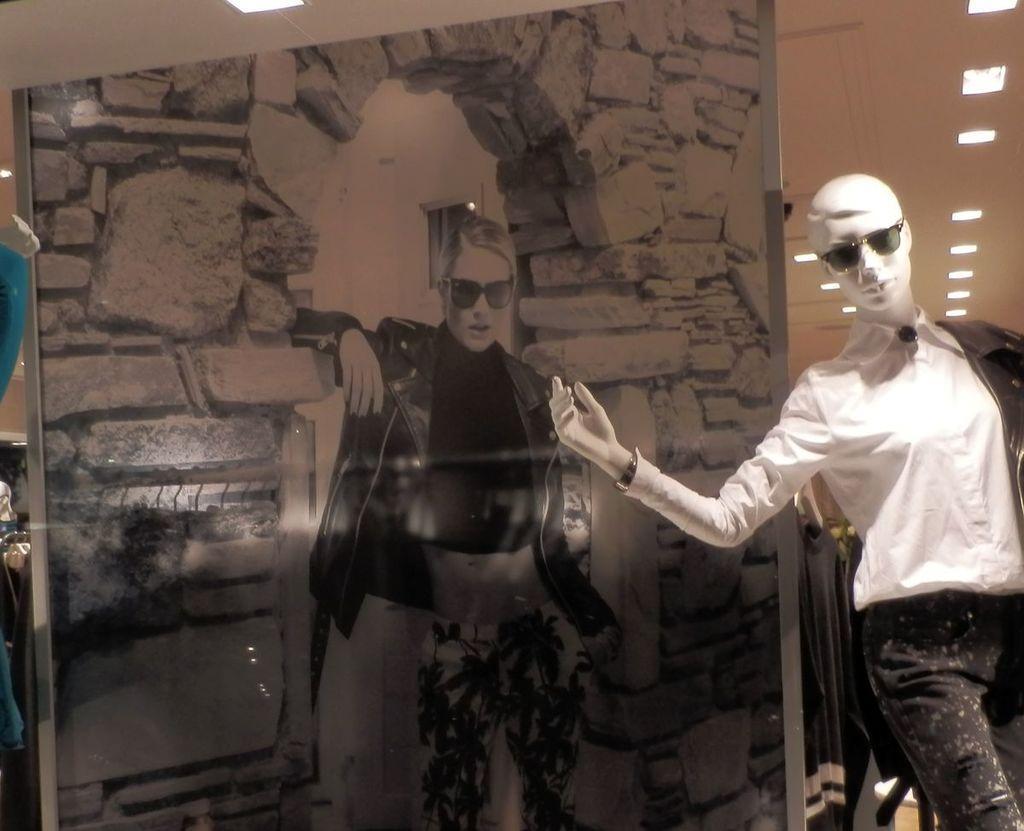Could you give a brief overview of what you see in this image? In the picture we can see a mannequin in the show room with white dress and behind it, we can see a painting of a person image standing and to the ceiling we can see the lights. 